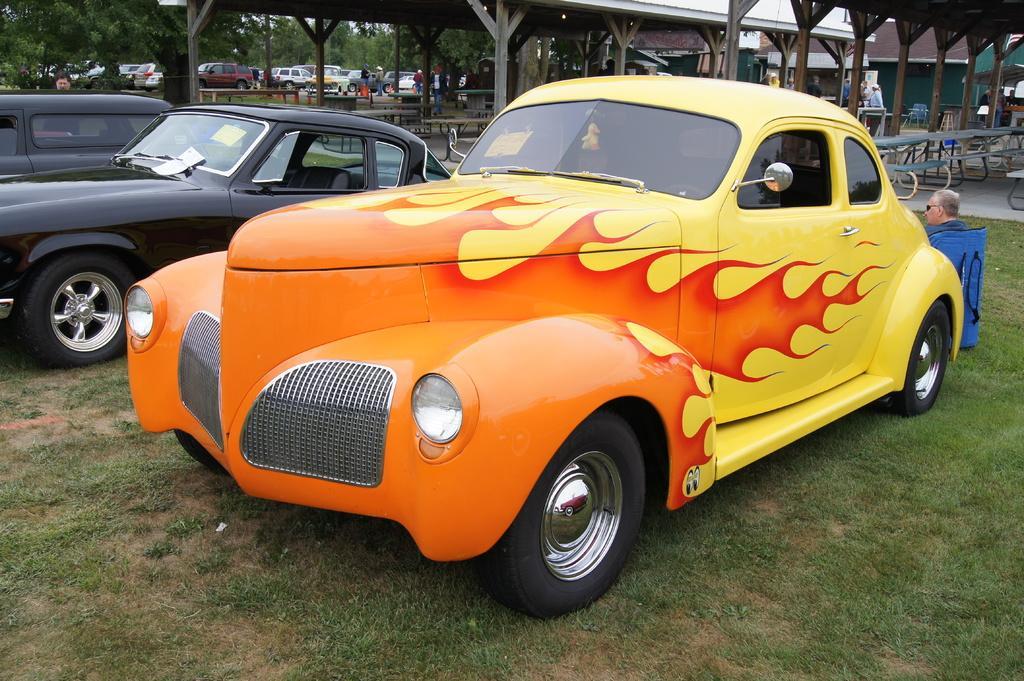Describe this image in one or two sentences. In the foreground of the picture I can see three cars. I can see a man on the right side. In the background, I can see the trees and cars. I can see the tables and the benches arrangements on the right side 